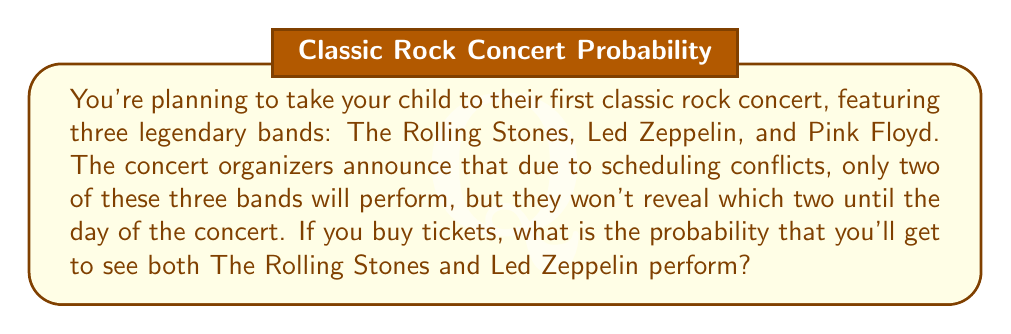Give your solution to this math problem. Let's approach this step-by-step:

1) First, we need to understand what outcomes are possible. There are three possible combinations of two bands:
   - The Rolling Stones and Led Zeppelin
   - The Rolling Stones and Pink Floyd
   - Led Zeppelin and Pink Floyd

2) We're interested in the probability of seeing both The Rolling Stones and Led Zeppelin. This is just one of the three possible outcomes.

3) Assuming each combination is equally likely (the organizers haven't given us any reason to think otherwise), we can use the classical definition of probability:

   $$P(\text{event}) = \frac{\text{number of favorable outcomes}}{\text{total number of possible outcomes}}$$

4) In this case:
   - Number of favorable outcomes = 1 (The Rolling Stones and Led Zeppelin performing)
   - Total number of possible outcomes = 3

5) Therefore, the probability is:

   $$P(\text{Rolling Stones and Led Zeppelin}) = \frac{1}{3}$$

This means there's a one-in-three chance of seeing both The Rolling Stones and Led Zeppelin at this concert.
Answer: $\frac{1}{3}$ 